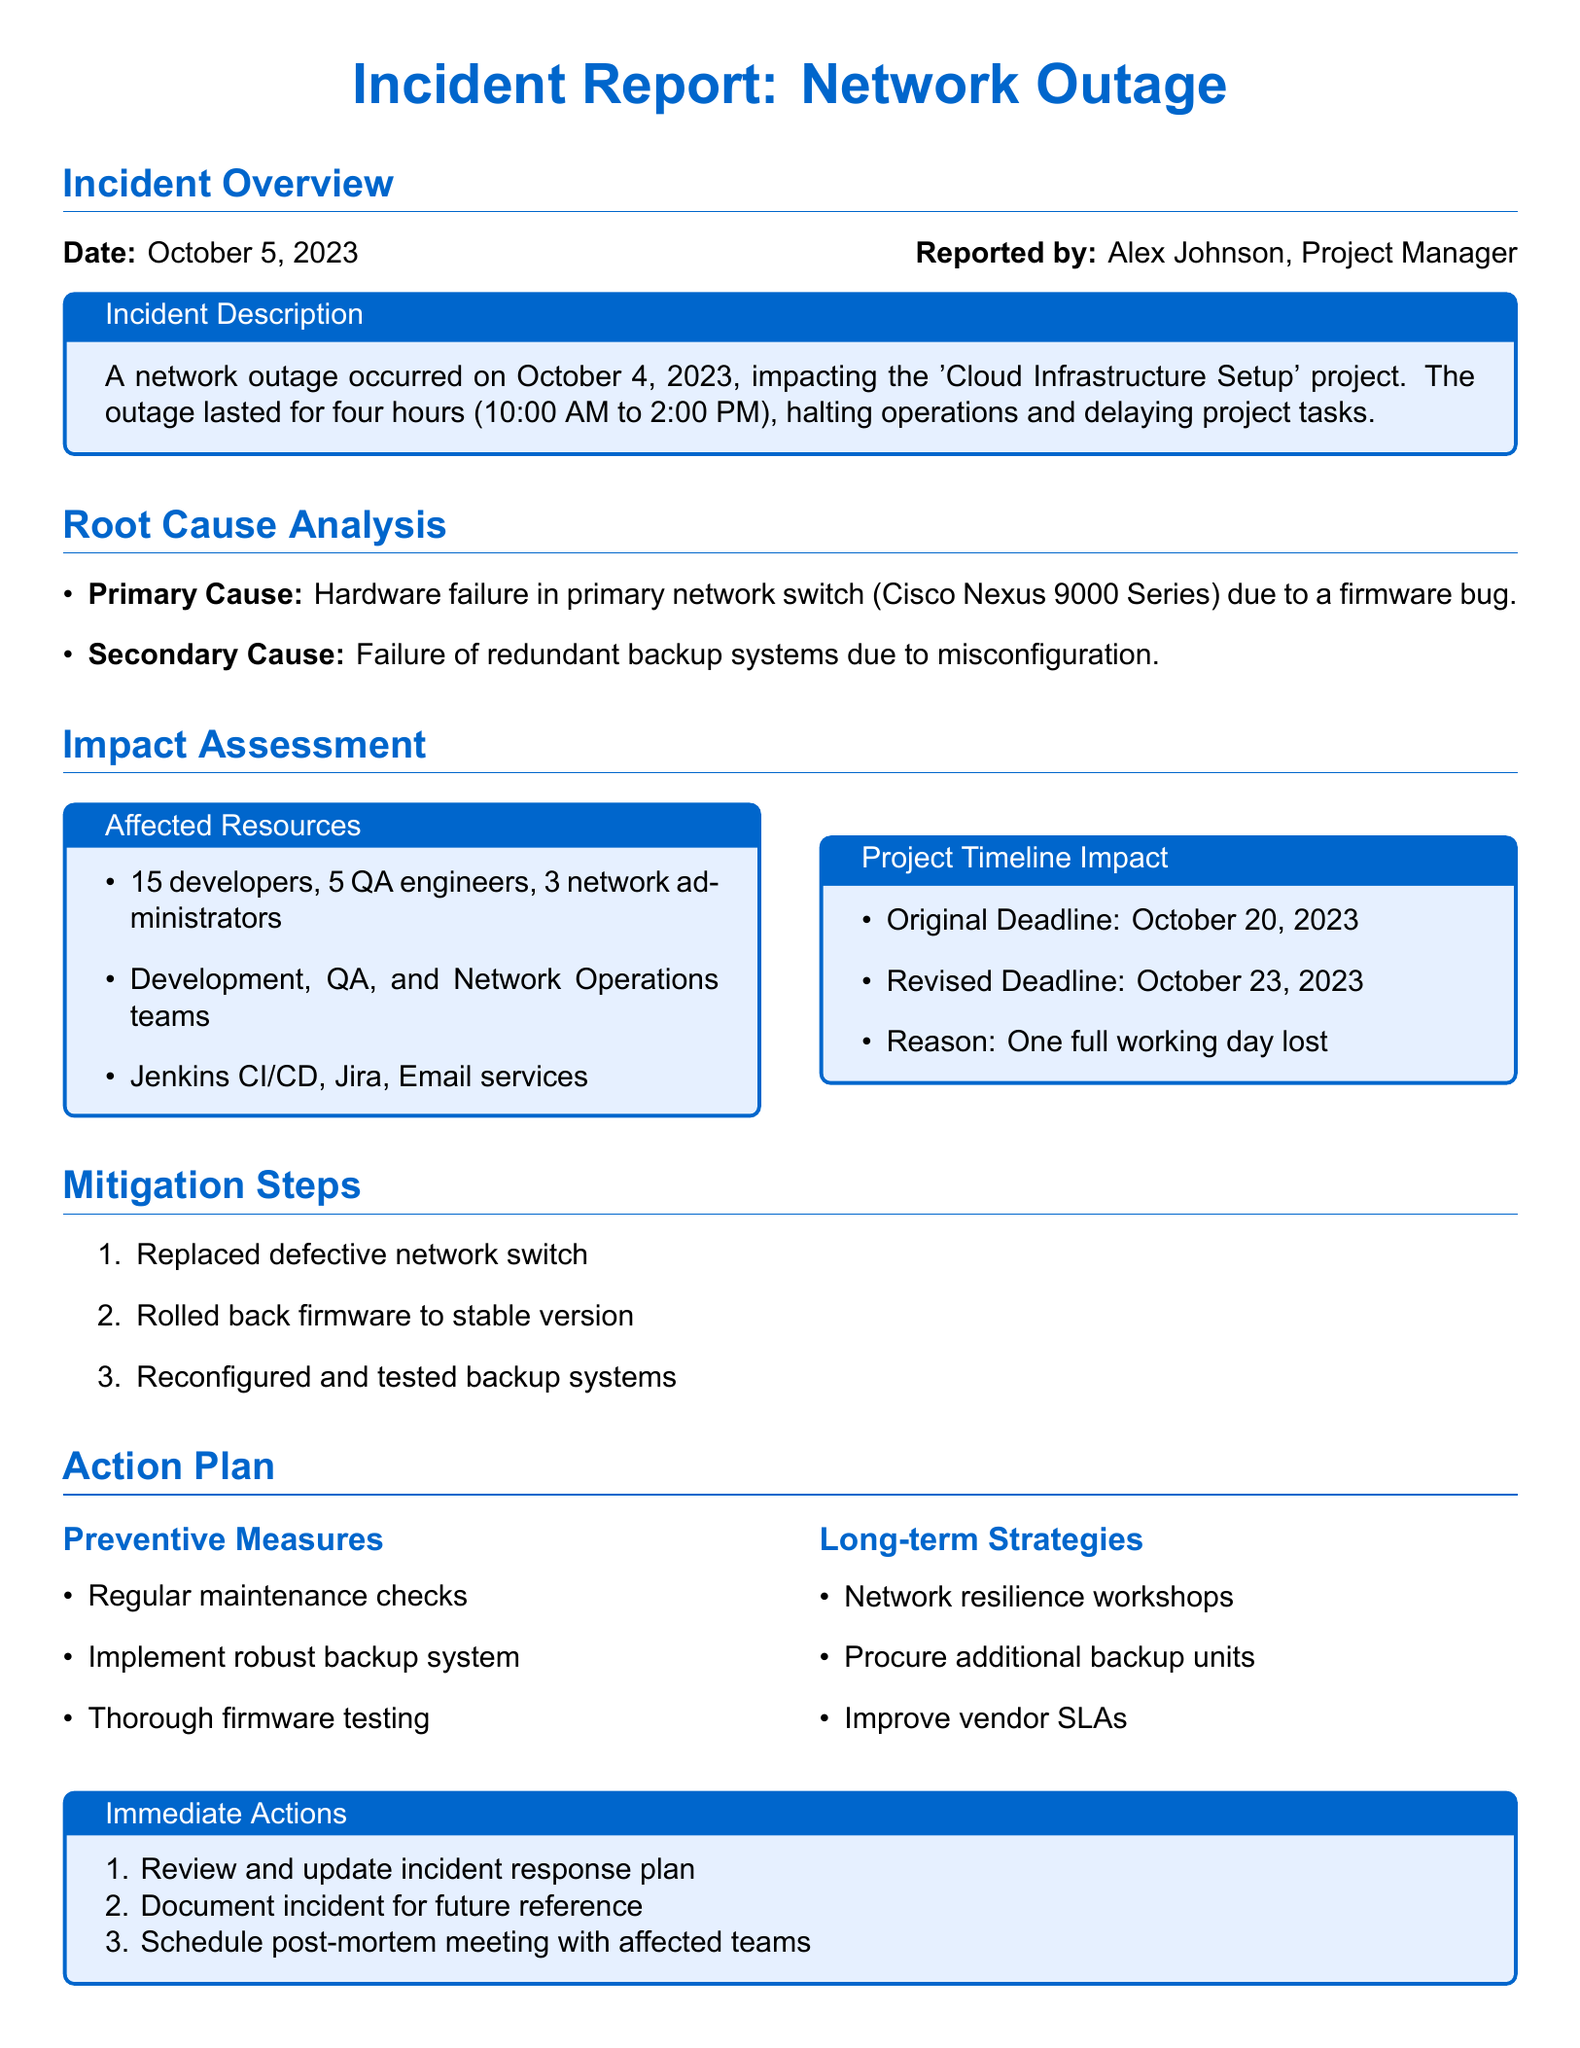What is the date of the network outage? The incident report states that the network outage occurred on October 4, 2023.
Answer: October 4, 2023 Who reported the incident? The report mentions Alex Johnson as the person who reported the incident.
Answer: Alex Johnson What was the original project deadline? The document indicates that the original deadline for the project was October 20, 2023.
Answer: October 20, 2023 How many hours did the outage last? The report specifies that the outage lasted for four hours.
Answer: Four hours What is the primary cause of the outage? The document states that the primary cause of the outage was a hardware failure in the primary network switch.
Answer: Hardware failure in primary network switch What is one of the preventive measures listed in the action plan? The incident report includes regular maintenance checks as a preventive measure.
Answer: Regular maintenance checks What was the revised project deadline after the outage? The report indicates that the revised deadline was October 23, 2023.
Answer: October 23, 2023 How many developers were affected by the outage? The report notes that 15 developers were affected by the outage.
Answer: 15 developers What immediate action is recommended after the incident? The report recommends reviewing and updating the incident response plan as an immediate action.
Answer: Review and update incident response plan 